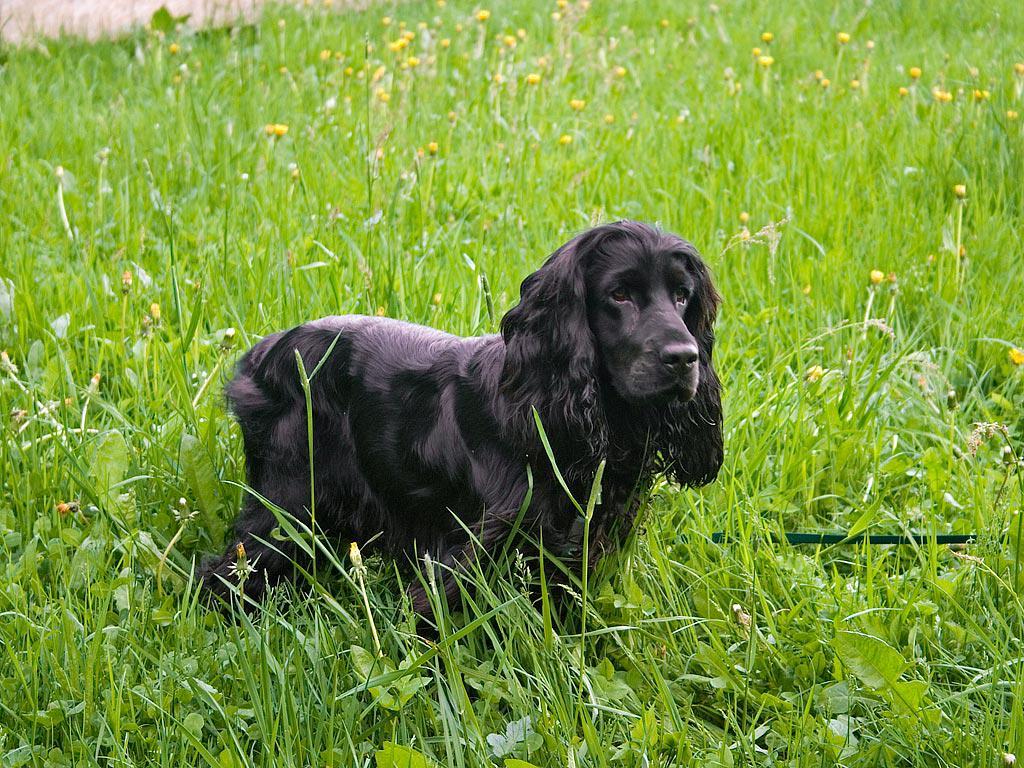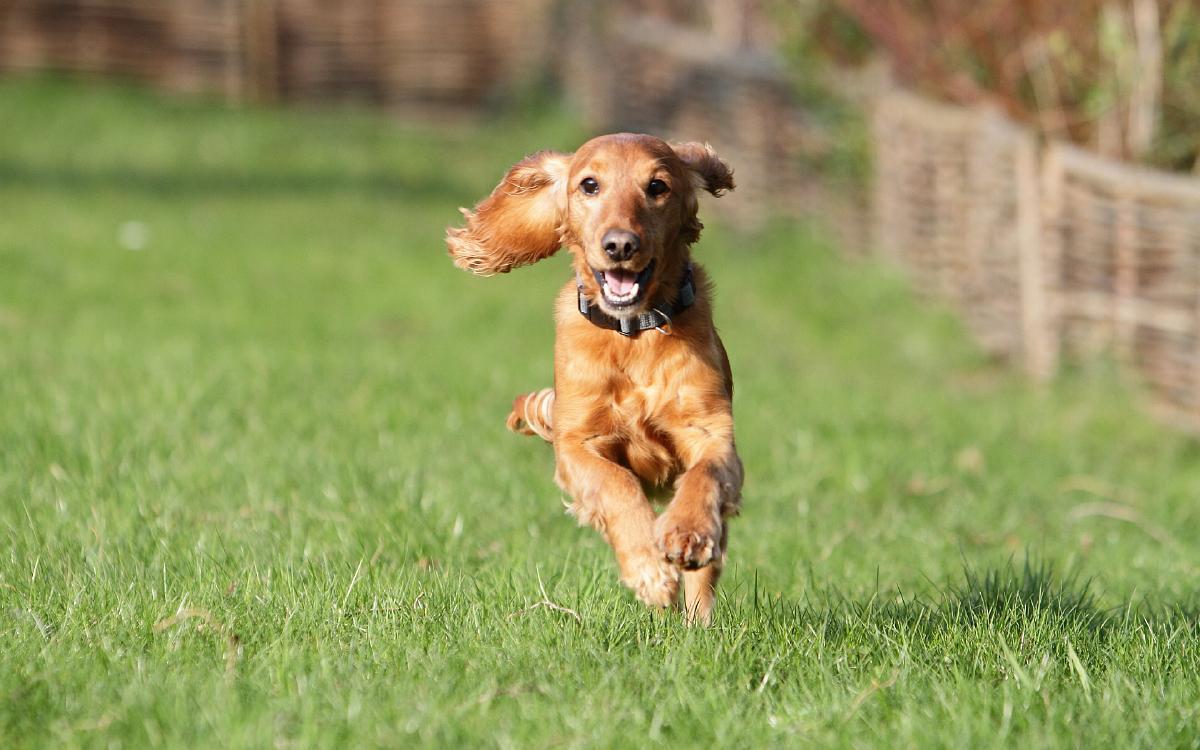The first image is the image on the left, the second image is the image on the right. Examine the images to the left and right. Is the description "One dog's body is turned towards the right." accurate? Answer yes or no. Yes. The first image is the image on the left, the second image is the image on the right. Given the left and right images, does the statement "The right image features one orange cocker spaniel standing on all fours in profile, and the left image features a spaniel with dark fur on the ears and eyes and lighter body fur." hold true? Answer yes or no. No. 